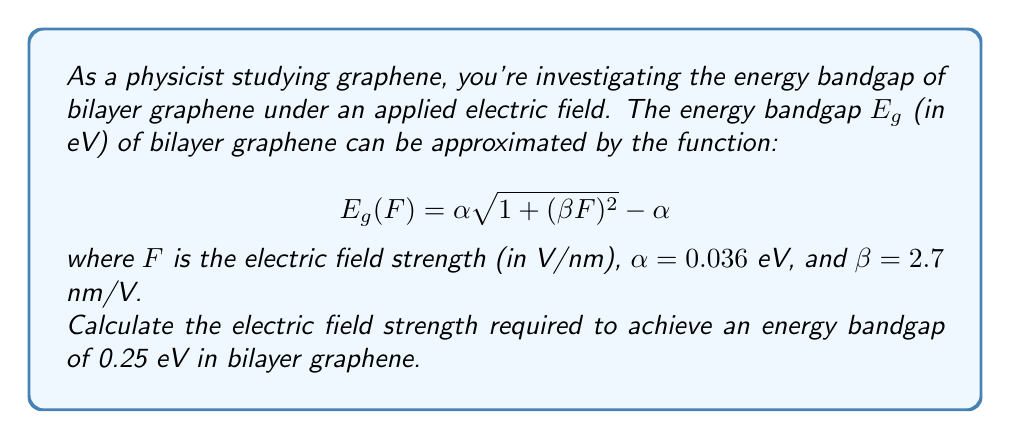Help me with this question. To solve this problem, we need to follow these steps:

1) We start with the given equation:
   $$E_g(F) = \alpha \sqrt{1 + (\beta F)^2} - \alpha$$

2) We're given that $\alpha = 0.036$ eV and $\beta = 2.7$ nm/V. We need to find $F$ when $E_g = 0.25$ eV.

3) Let's substitute these values into the equation:
   $$0.25 = 0.036 \sqrt{1 + (2.7F)^2} - 0.036$$

4) Add 0.036 to both sides:
   $$0.286 = 0.036 \sqrt{1 + (2.7F)^2}$$

5) Divide both sides by 0.036:
   $$7.9444 = \sqrt{1 + (2.7F)^2}$$

6) Square both sides:
   $$63.1138 = 1 + (2.7F)^2$$

7) Subtract 1 from both sides:
   $$62.1138 = (2.7F)^2$$

8) Divide both sides by $(2.7)^2$:
   $$8.5235 = F^2$$

9) Take the square root of both sides:
   $$F = \sqrt{8.5235} \approx 2.9195$$

Therefore, the electric field strength required is approximately 2.9195 V/nm.
Answer: $F \approx 2.9195$ V/nm 